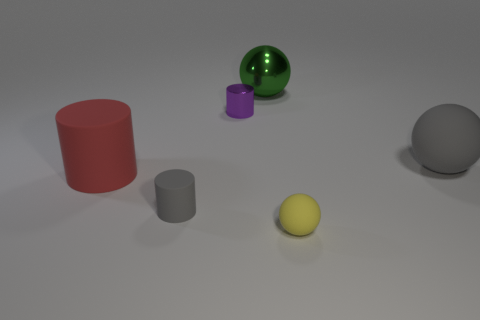Add 3 small yellow rubber spheres. How many objects exist? 9 Add 3 purple things. How many purple things are left? 4 Add 4 big gray metallic spheres. How many big gray metallic spheres exist? 4 Subtract 0 purple cubes. How many objects are left? 6 Subtract all gray balls. Subtract all large red metal balls. How many objects are left? 5 